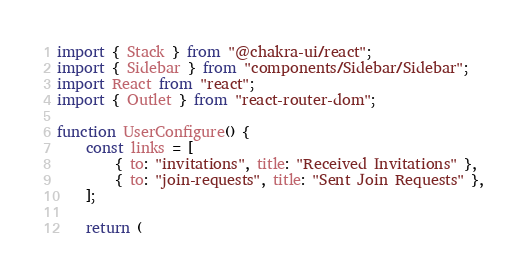<code> <loc_0><loc_0><loc_500><loc_500><_TypeScript_>import { Stack } from "@chakra-ui/react";
import { Sidebar } from "components/Sidebar/Sidebar";
import React from "react";
import { Outlet } from "react-router-dom";

function UserConfigure() {
    const links = [
        { to: "invitations", title: "Received Invitations" },
        { to: "join-requests", title: "Sent Join Requests" },
    ];

    return (</code> 